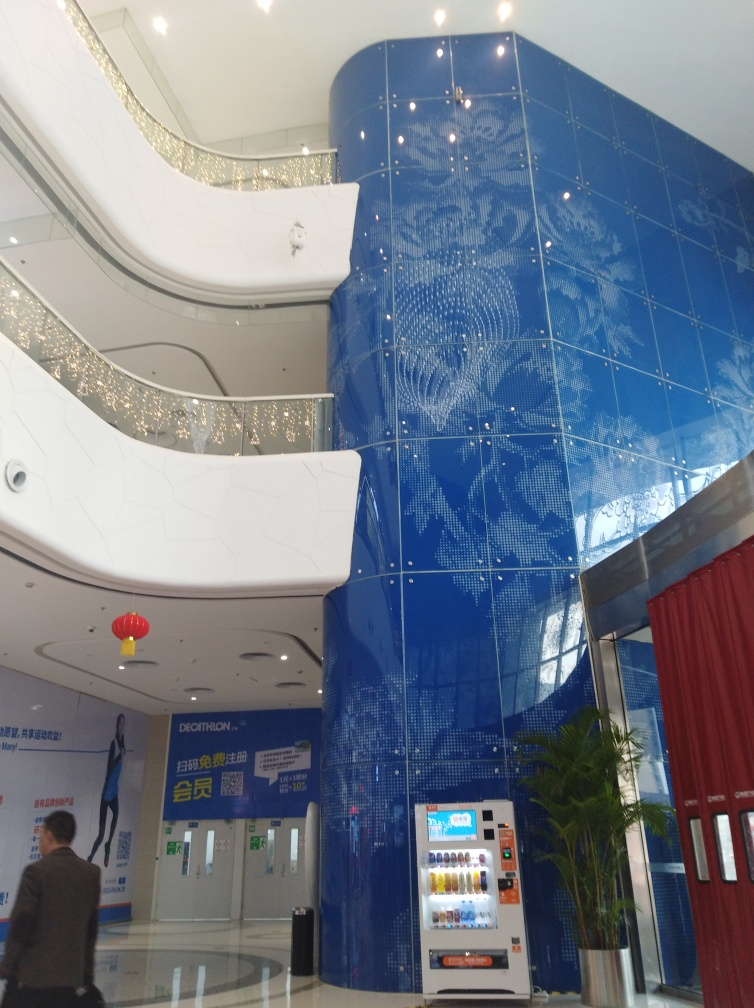What kind of patterns can be observed on the wall and what might they represent? The patterns on the wall are intricate and seem to represent a stylized map of the world, emphasizing a theme of global connectivity and travel, which could be indicative of a building related to international affairs or a corporate global enterprise. 